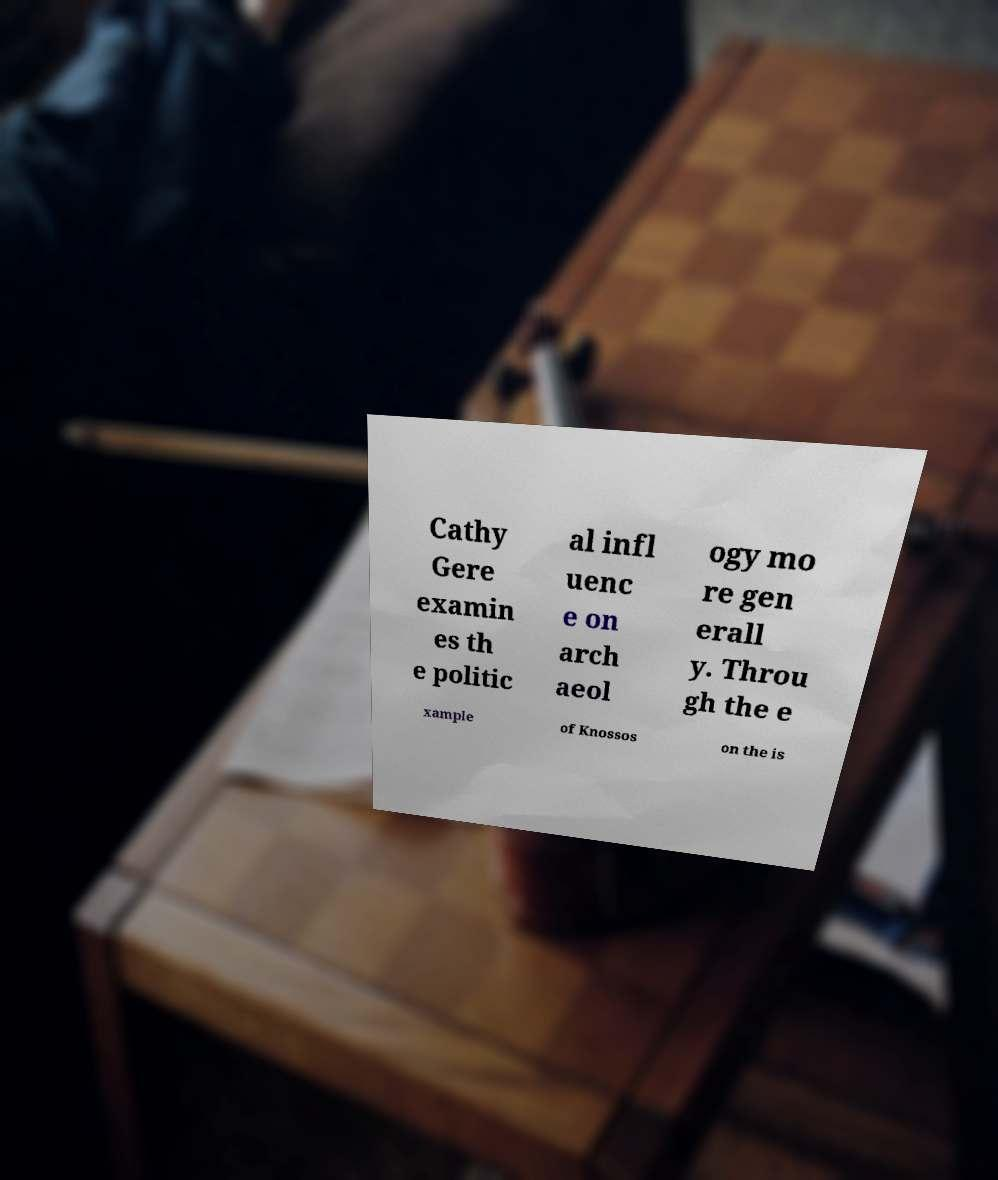Could you assist in decoding the text presented in this image and type it out clearly? Cathy Gere examin es th e politic al infl uenc e on arch aeol ogy mo re gen erall y. Throu gh the e xample of Knossos on the is 